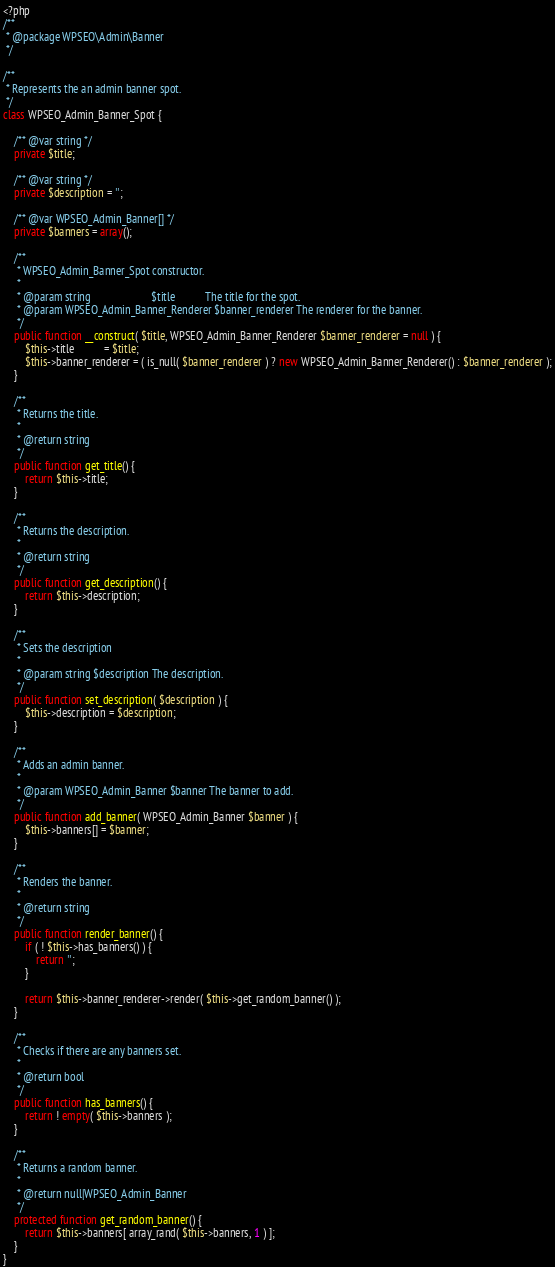<code> <loc_0><loc_0><loc_500><loc_500><_PHP_><?php
/**
 * @package WPSEO\Admin\Banner
 */

/**
 * Represents the an admin banner spot.
 */
class WPSEO_Admin_Banner_Spot {

	/** @var string */
	private $title;

	/** @var string */
	private $description = '';

	/** @var WPSEO_Admin_Banner[] */
	private $banners = array();

	/**
	 * WPSEO_Admin_Banner_Spot constructor.
	 *
	 * @param string                      $title           The title for the spot.
	 * @param WPSEO_Admin_Banner_Renderer $banner_renderer The renderer for the banner.
	 */
	public function __construct( $title, WPSEO_Admin_Banner_Renderer $banner_renderer = null ) {
		$this->title           = $title;
		$this->banner_renderer = ( is_null( $banner_renderer ) ? new WPSEO_Admin_Banner_Renderer() : $banner_renderer );
	}

	/**
	 * Returns the title.
	 *
	 * @return string
	 */
	public function get_title() {
		return $this->title;
	}

	/**
	 * Returns the description.
	 *
	 * @return string
	 */
	public function get_description() {
		return $this->description;
	}

	/**
	 * Sets the description
	 *
	 * @param string $description The description.
	 */
	public function set_description( $description ) {
		$this->description = $description;
	}

	/**
	 * Adds an admin banner.
	 *
	 * @param WPSEO_Admin_Banner $banner The banner to add.
	 */
	public function add_banner( WPSEO_Admin_Banner $banner ) {
		$this->banners[] = $banner;
	}

	/**
	 * Renders the banner.
	 *
	 * @return string
	 */
	public function render_banner() {
		if ( ! $this->has_banners() ) {
			return '';
		}

		return $this->banner_renderer->render( $this->get_random_banner() );
	}

	/**
	 * Checks if there are any banners set.
	 *
	 * @return bool
	 */
	public function has_banners() {
		return ! empty( $this->banners );
	}

	/**
	 * Returns a random banner.
	 *
	 * @return null|WPSEO_Admin_Banner
	 */
	protected function get_random_banner() {
		return $this->banners[ array_rand( $this->banners, 1 ) ];
	}
}
</code> 